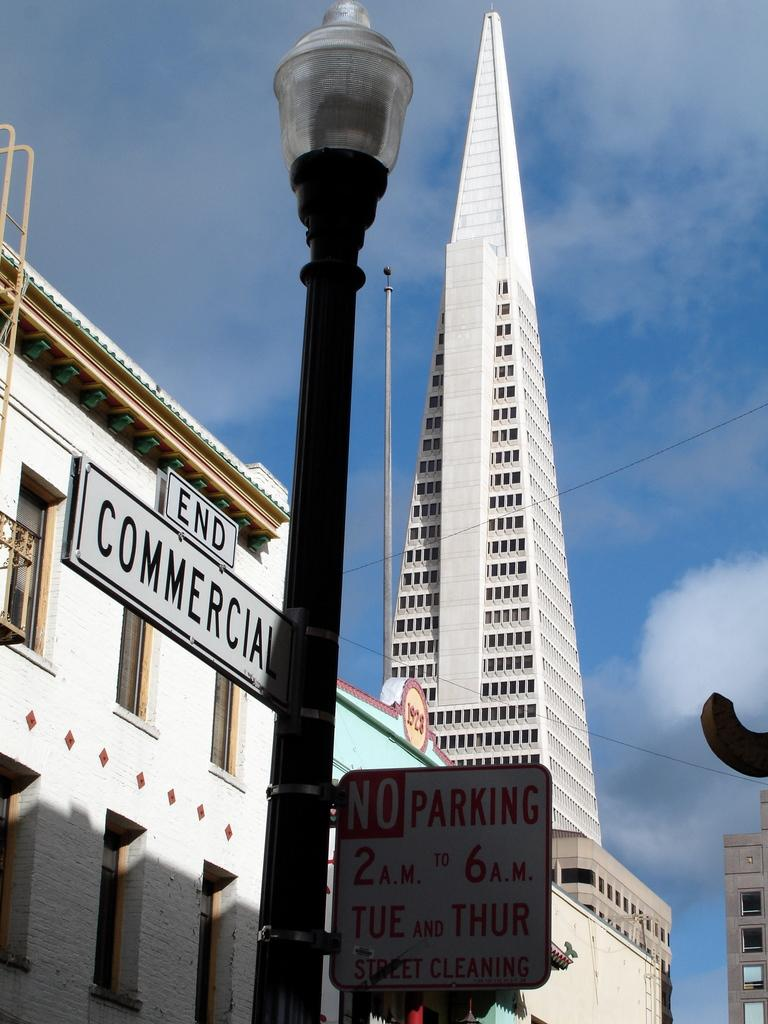What type of structures can be seen in the image? There are buildings in the image. What type of information might be conveyed by the sign boards in the image? The sign boards in the image might convey information about directions, businesses, or events. What type of lighting is present in the image? There are street lamps on poles in the image. What type of crime is being committed in the image? There is no indication of any crime being committed in the image. What type of flame can be seen coming from the street lamps in the image? There are no flames present in the image; the street lamps are likely electric. 